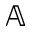<formula> <loc_0><loc_0><loc_500><loc_500>\mathbb { A }</formula> 